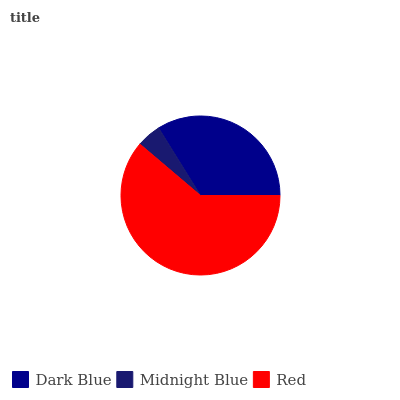Is Midnight Blue the minimum?
Answer yes or no. Yes. Is Red the maximum?
Answer yes or no. Yes. Is Red the minimum?
Answer yes or no. No. Is Midnight Blue the maximum?
Answer yes or no. No. Is Red greater than Midnight Blue?
Answer yes or no. Yes. Is Midnight Blue less than Red?
Answer yes or no. Yes. Is Midnight Blue greater than Red?
Answer yes or no. No. Is Red less than Midnight Blue?
Answer yes or no. No. Is Dark Blue the high median?
Answer yes or no. Yes. Is Dark Blue the low median?
Answer yes or no. Yes. Is Midnight Blue the high median?
Answer yes or no. No. Is Red the low median?
Answer yes or no. No. 